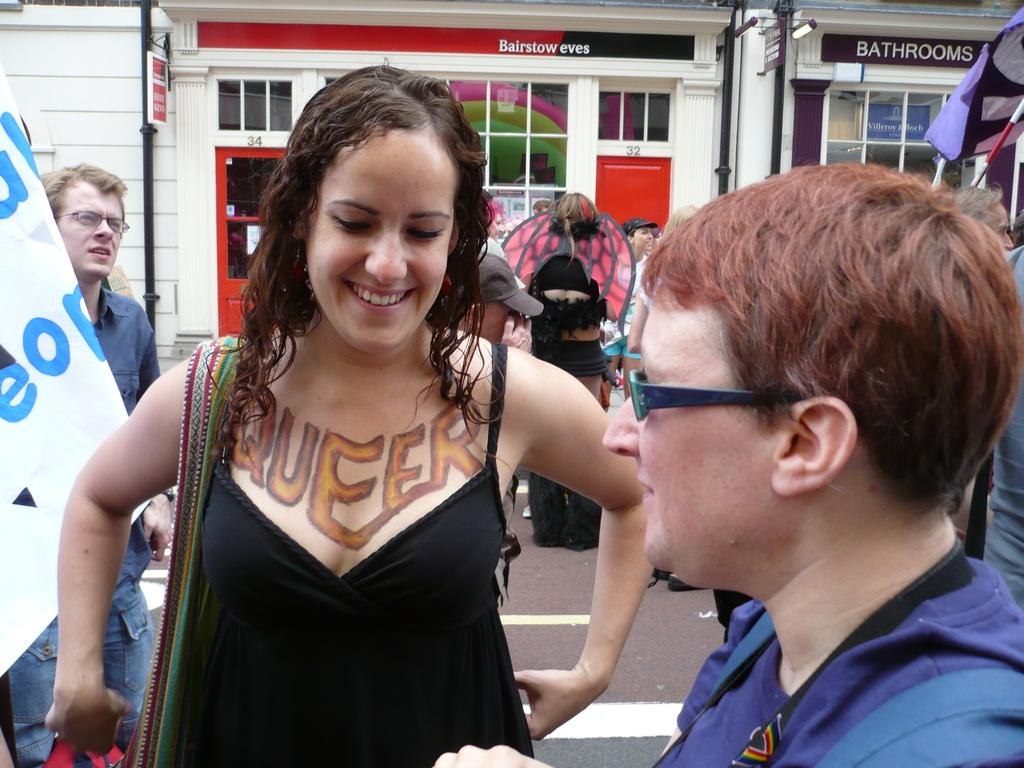Who is the main subject in the image? There is a lady in the image. What is the lady doing in the image? The lady is smiling. Are there any other people in the image besides the lady? Yes, there are other people in the image. What are some of the people doing in the image? Some of the people are holding flags. What can be seen in the background of the image? There are buildings in the background of the image. What type of plants can be seen growing on the slope in the image? There is no slope or plants present in the image. 